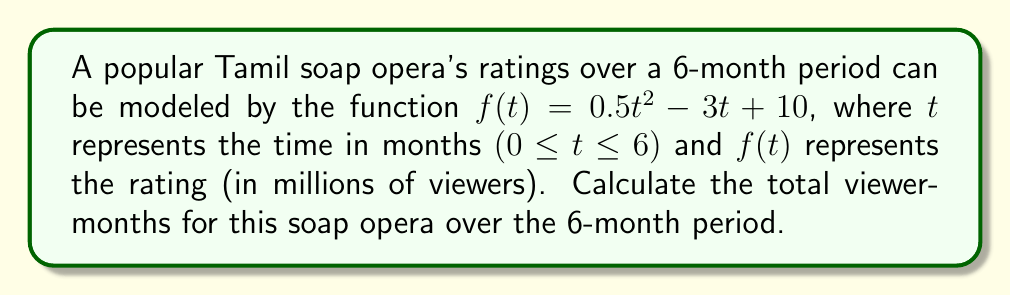Provide a solution to this math problem. To find the total viewer-months, we need to calculate the area under the curve of the ratings function from $t=0$ to $t=6$. This can be done using definite integration:

1) The integral we need to evaluate is:
   $$\int_0^6 (0.5t^2 - 3t + 10) \, dt$$

2) Integrate each term:
   $$\left[\frac{0.5t^3}{3} - \frac{3t^2}{2} + 10t\right]_0^6$$

3) Evaluate at the upper and lower bounds:
   $$\left(\frac{0.5(6^3)}{3} - \frac{3(6^2)}{2} + 10(6)\right) - \left(\frac{0.5(0^3)}{3} - \frac{3(0^2)}{2} + 10(0)\right)$$

4) Simplify:
   $$\left(36 - 54 + 60\right) - (0)$$

5) Calculate the final result:
   $$42 \text{ million viewer-months}$$
Answer: 42 million viewer-months 